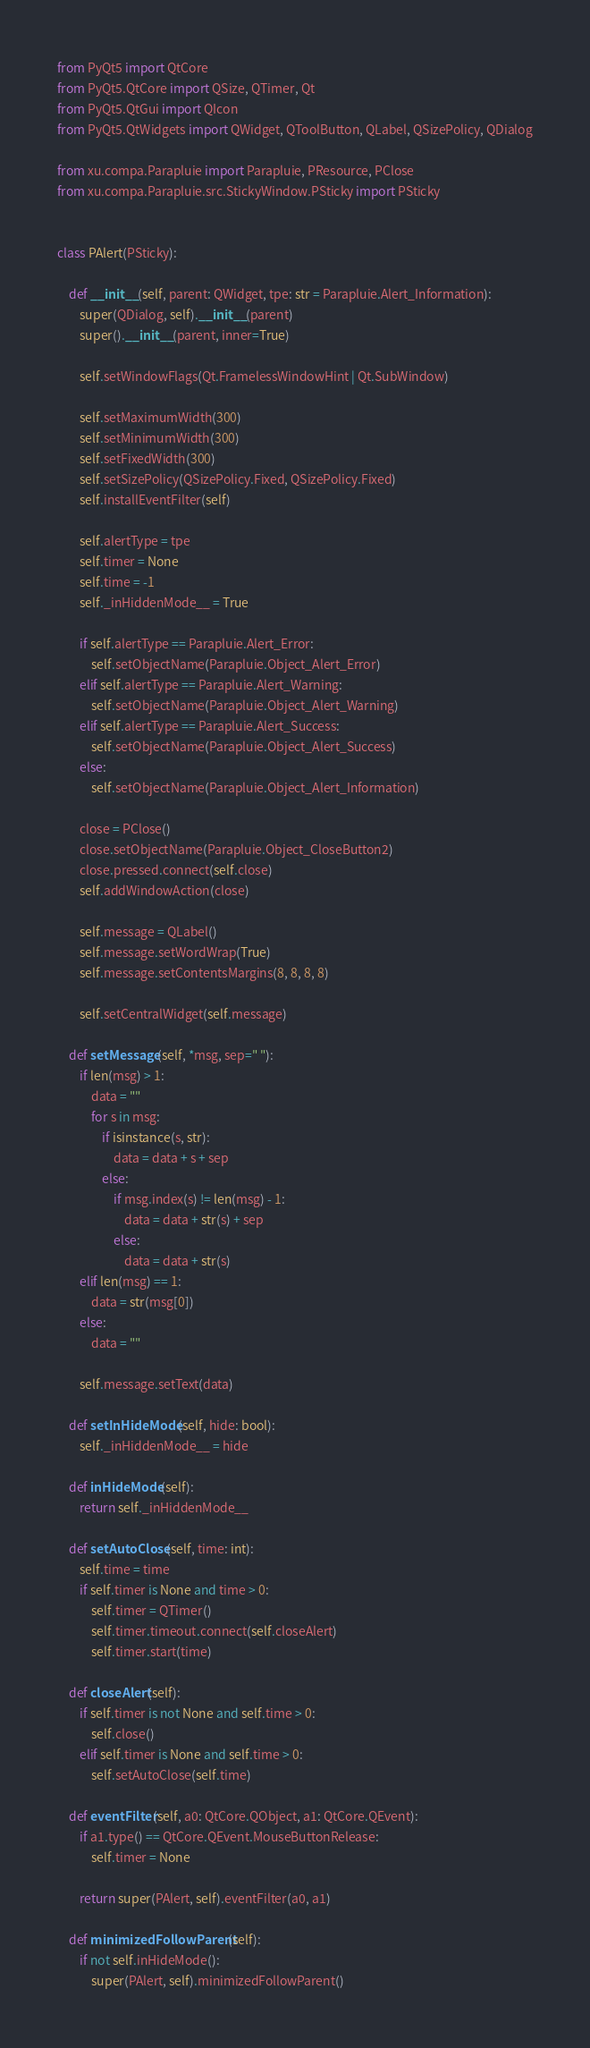<code> <loc_0><loc_0><loc_500><loc_500><_Python_>from PyQt5 import QtCore
from PyQt5.QtCore import QSize, QTimer, Qt
from PyQt5.QtGui import QIcon
from PyQt5.QtWidgets import QWidget, QToolButton, QLabel, QSizePolicy, QDialog

from xu.compa.Parapluie import Parapluie, PResource, PClose
from xu.compa.Parapluie.src.StickyWindow.PSticky import PSticky


class PAlert(PSticky):

    def __init__(self, parent: QWidget, tpe: str = Parapluie.Alert_Information):
        super(QDialog, self).__init__(parent)
        super().__init__(parent, inner=True)

        self.setWindowFlags(Qt.FramelessWindowHint | Qt.SubWindow)

        self.setMaximumWidth(300)
        self.setMinimumWidth(300)
        self.setFixedWidth(300)
        self.setSizePolicy(QSizePolicy.Fixed, QSizePolicy.Fixed)
        self.installEventFilter(self)

        self.alertType = tpe
        self.timer = None
        self.time = -1
        self._inHiddenMode__ = True

        if self.alertType == Parapluie.Alert_Error:
            self.setObjectName(Parapluie.Object_Alert_Error)
        elif self.alertType == Parapluie.Alert_Warning:
            self.setObjectName(Parapluie.Object_Alert_Warning)
        elif self.alertType == Parapluie.Alert_Success:
            self.setObjectName(Parapluie.Object_Alert_Success)
        else:
            self.setObjectName(Parapluie.Object_Alert_Information)

        close = PClose()
        close.setObjectName(Parapluie.Object_CloseButton2)
        close.pressed.connect(self.close)
        self.addWindowAction(close)

        self.message = QLabel()
        self.message.setWordWrap(True)
        self.message.setContentsMargins(8, 8, 8, 8)

        self.setCentralWidget(self.message)

    def setMessage(self, *msg, sep=" "):
        if len(msg) > 1:
            data = ""
            for s in msg:
                if isinstance(s, str):
                    data = data + s + sep
                else:
                    if msg.index(s) != len(msg) - 1:
                        data = data + str(s) + sep
                    else:
                        data = data + str(s)
        elif len(msg) == 1:
            data = str(msg[0])
        else:
            data = ""

        self.message.setText(data)

    def setInHideMode(self, hide: bool):
        self._inHiddenMode__ = hide

    def inHideMode(self):
        return self._inHiddenMode__

    def setAutoClose(self, time: int):
        self.time = time
        if self.timer is None and time > 0:
            self.timer = QTimer()
            self.timer.timeout.connect(self.closeAlert)
            self.timer.start(time)

    def closeAlert(self):
        if self.timer is not None and self.time > 0:
            self.close()
        elif self.timer is None and self.time > 0:
            self.setAutoClose(self.time)

    def eventFilter(self, a0: QtCore.QObject, a1: QtCore.QEvent):
        if a1.type() == QtCore.QEvent.MouseButtonRelease:
            self.timer = None

        return super(PAlert, self).eventFilter(a0, a1)

    def minimizedFollowParent(self):
        if not self.inHideMode():
            super(PAlert, self).minimizedFollowParent()
</code> 